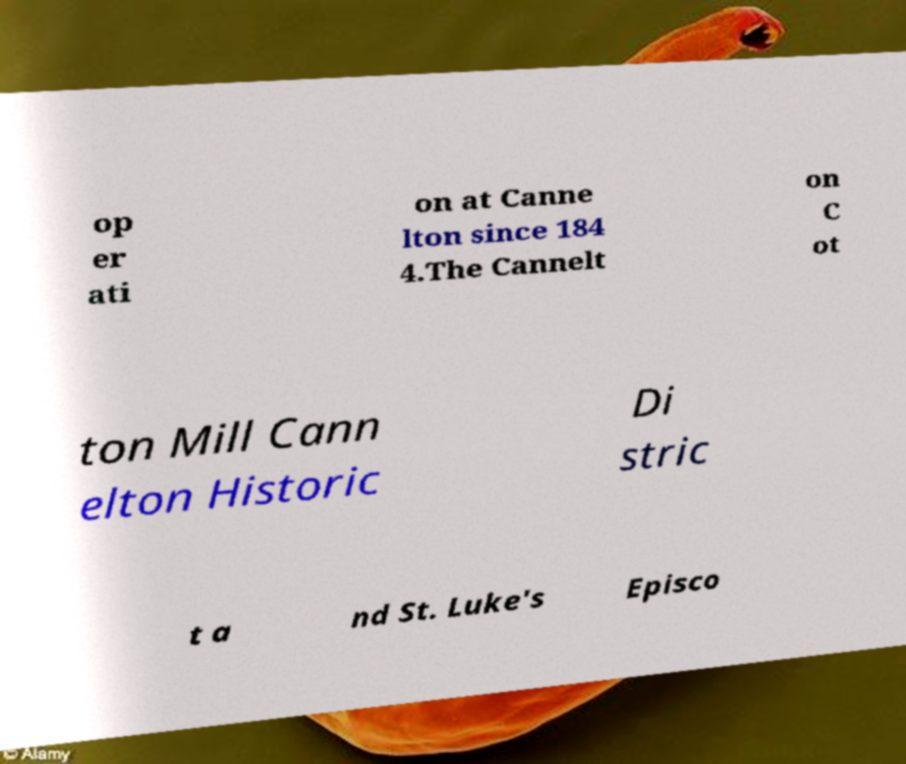For documentation purposes, I need the text within this image transcribed. Could you provide that? op er ati on at Canne lton since 184 4.The Cannelt on C ot ton Mill Cann elton Historic Di stric t a nd St. Luke's Episco 